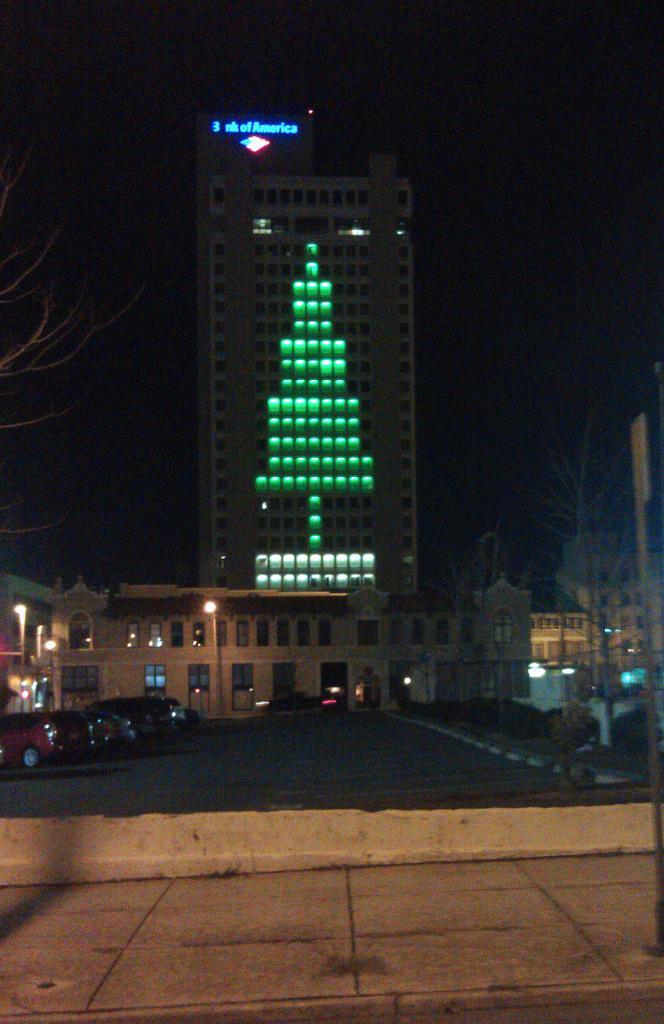Please provide a concise description of this image. In this picture there is a huge building with decorative green lights. In the front we can see some cars are parked in the parking area. In the front bottom side there is a flooring tiles. 